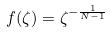Convert formula to latex. <formula><loc_0><loc_0><loc_500><loc_500>f ( \zeta ) = \zeta ^ { - \frac { 1 } { N - 1 } }</formula> 